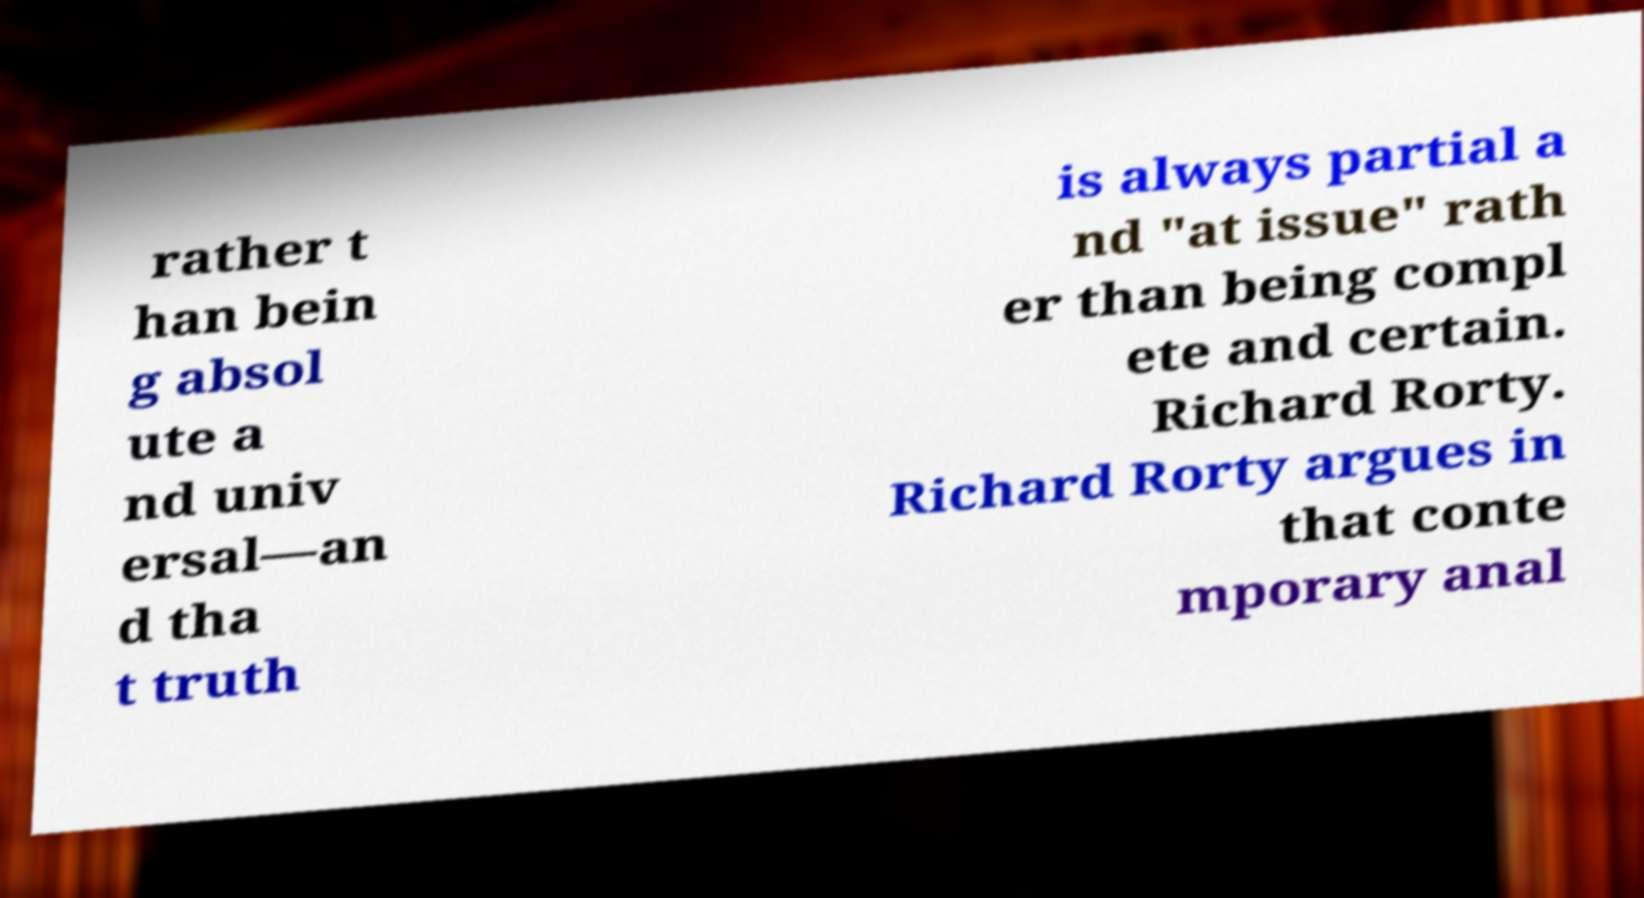There's text embedded in this image that I need extracted. Can you transcribe it verbatim? rather t han bein g absol ute a nd univ ersal—an d tha t truth is always partial a nd "at issue" rath er than being compl ete and certain. Richard Rorty. Richard Rorty argues in that conte mporary anal 